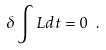Convert formula to latex. <formula><loc_0><loc_0><loc_500><loc_500>\delta \int L d t = 0 \ .</formula> 